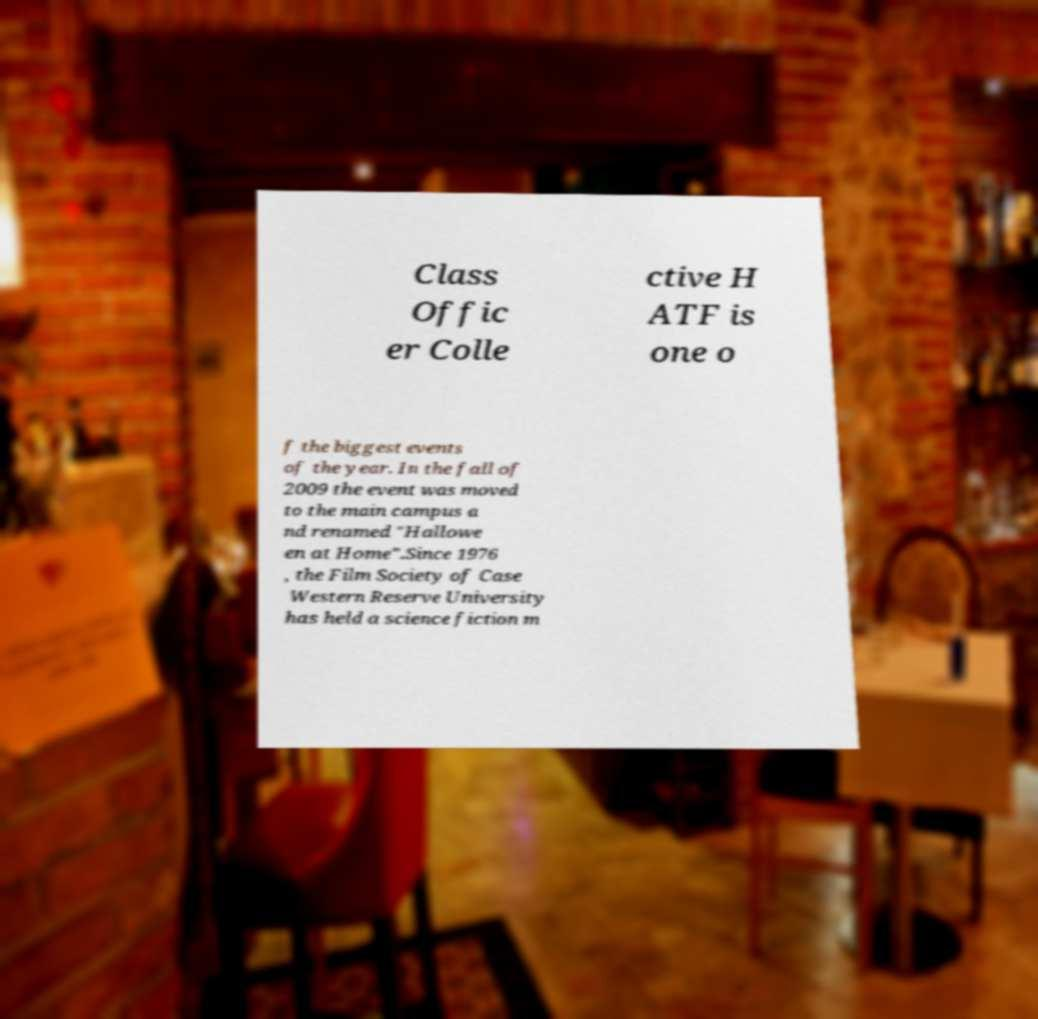Could you extract and type out the text from this image? Class Offic er Colle ctive H ATF is one o f the biggest events of the year. In the fall of 2009 the event was moved to the main campus a nd renamed "Hallowe en at Home".Since 1976 , the Film Society of Case Western Reserve University has held a science fiction m 